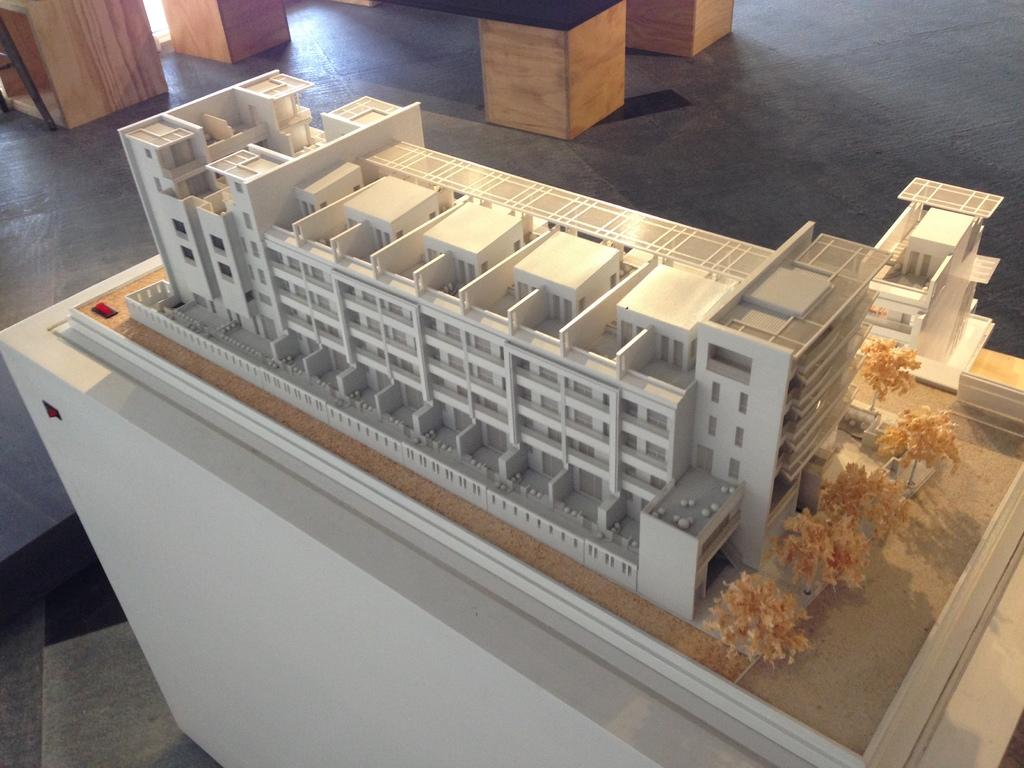What type of structure is present in the image? There is a building in the image. What other object can be seen in the image besides the building? There is a plane placed on a table in the image. What type of company is operating the train in the image? There is no train present in the image; it only features a building and a plane placed on a table. How is the power generated for the plane in the image? The image does not show any power generation for the plane; it only shows the plane placed on a table. 